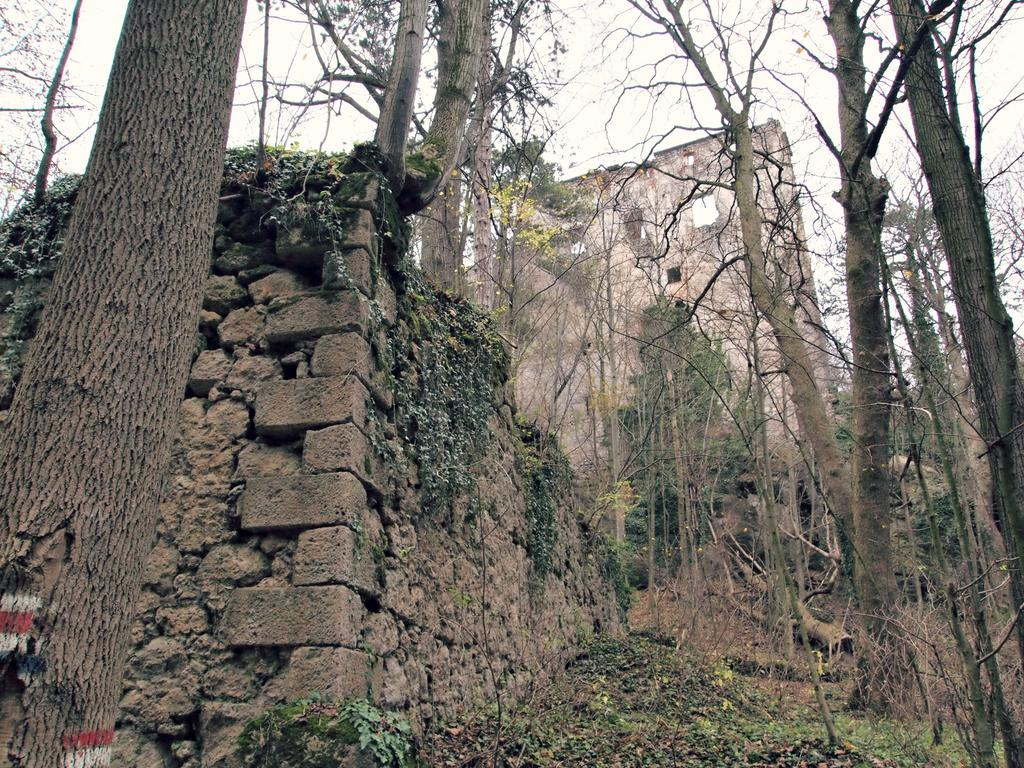What part of the trees can be seen in the image? The trunk of trees is visible in the image. What type of structure is on the left side of the image? There is a brick wall construction on the left side of the image. Can you describe the background of the image? There is another wall visible in the background of the image. What type of drink is being served in the image? There is no drink present in the image. What type of frame is surrounding the image? The image does not show a frame around it. 